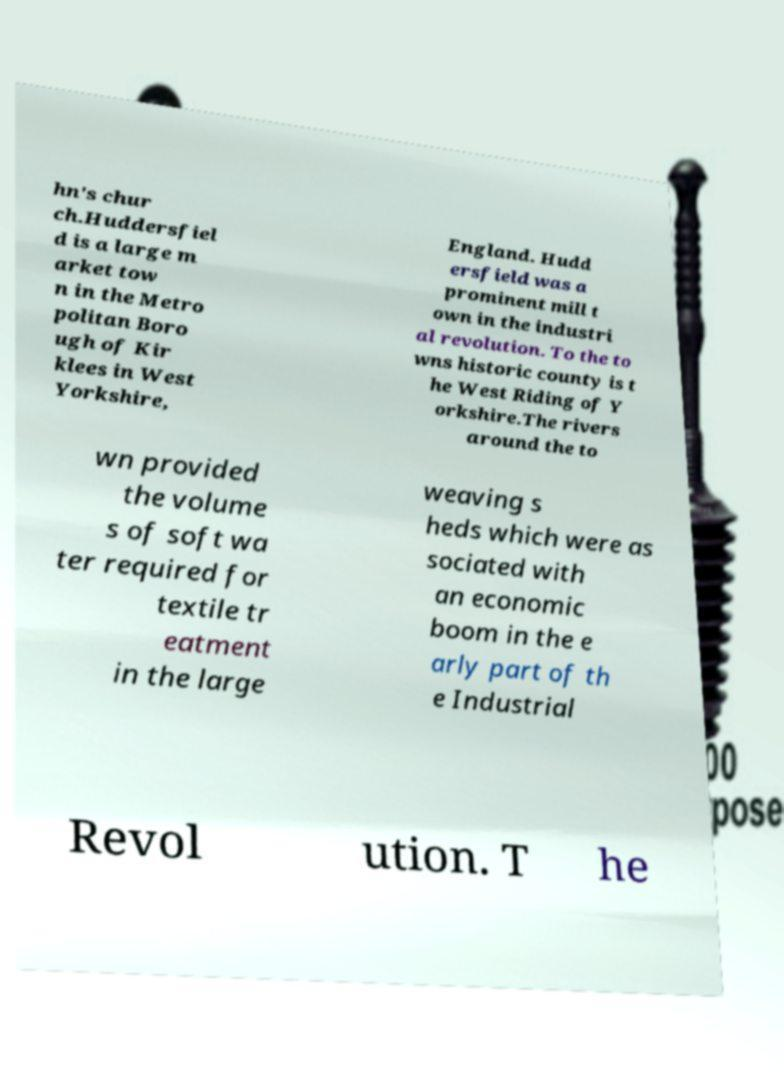Can you read and provide the text displayed in the image?This photo seems to have some interesting text. Can you extract and type it out for me? hn's chur ch.Huddersfiel d is a large m arket tow n in the Metro politan Boro ugh of Kir klees in West Yorkshire, England. Hudd ersfield was a prominent mill t own in the industri al revolution. To the to wns historic county is t he West Riding of Y orkshire.The rivers around the to wn provided the volume s of soft wa ter required for textile tr eatment in the large weaving s heds which were as sociated with an economic boom in the e arly part of th e Industrial Revol ution. T he 